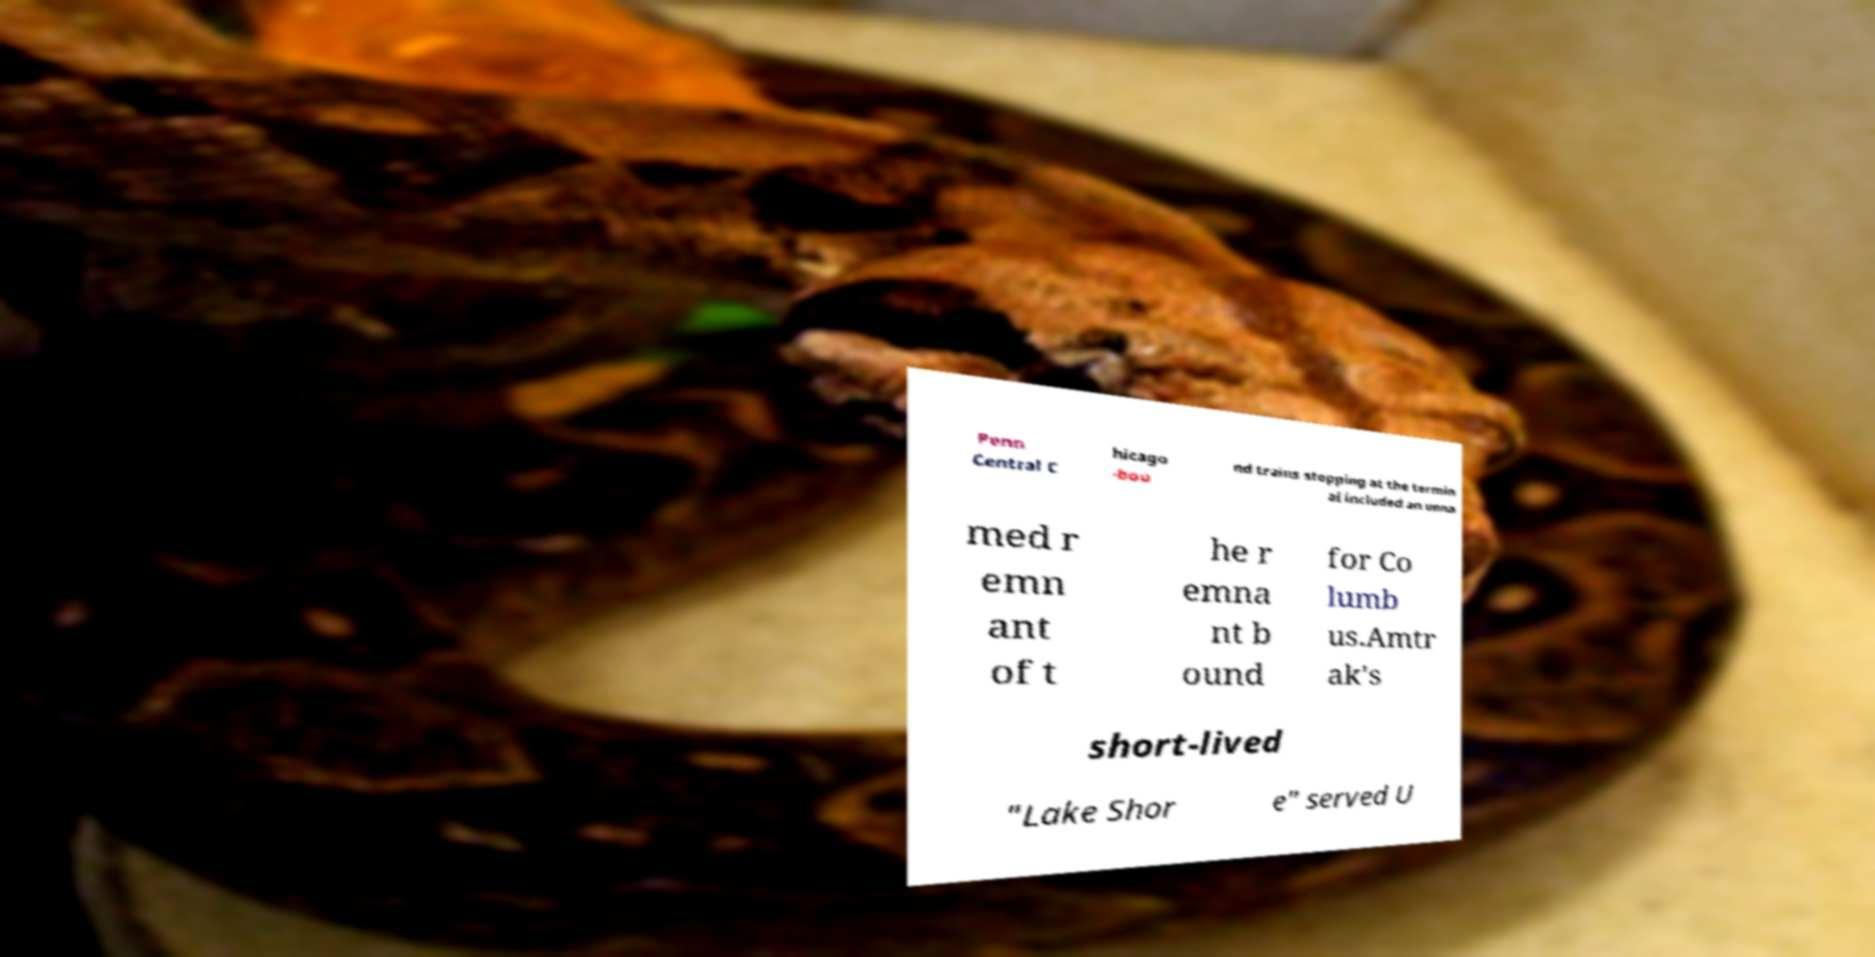Could you extract and type out the text from this image? Penn Central C hicago -bou nd trains stopping at the termin al included an unna med r emn ant of t he r emna nt b ound for Co lumb us.Amtr ak's short-lived "Lake Shor e" served U 